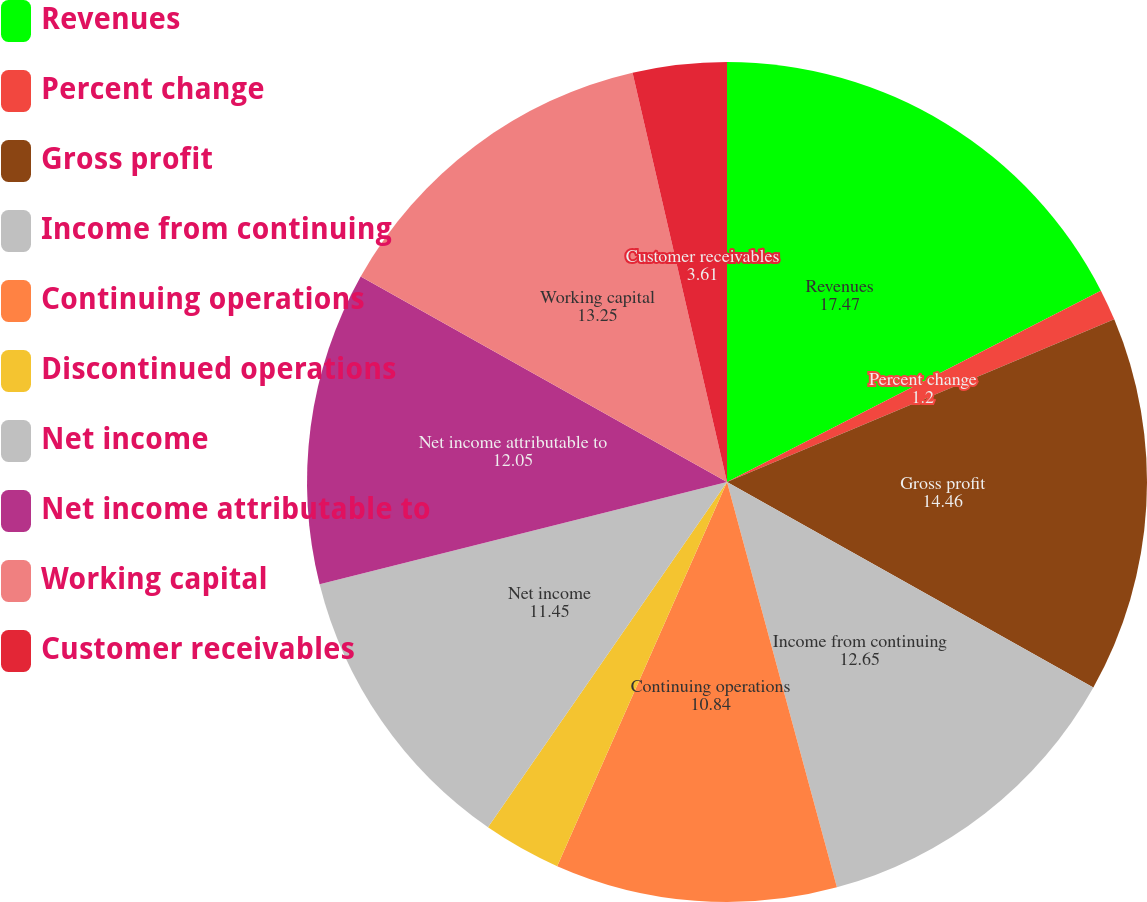Convert chart to OTSL. <chart><loc_0><loc_0><loc_500><loc_500><pie_chart><fcel>Revenues<fcel>Percent change<fcel>Gross profit<fcel>Income from continuing<fcel>Continuing operations<fcel>Discontinued operations<fcel>Net income<fcel>Net income attributable to<fcel>Working capital<fcel>Customer receivables<nl><fcel>17.47%<fcel>1.2%<fcel>14.46%<fcel>12.65%<fcel>10.84%<fcel>3.01%<fcel>11.45%<fcel>12.05%<fcel>13.25%<fcel>3.61%<nl></chart> 